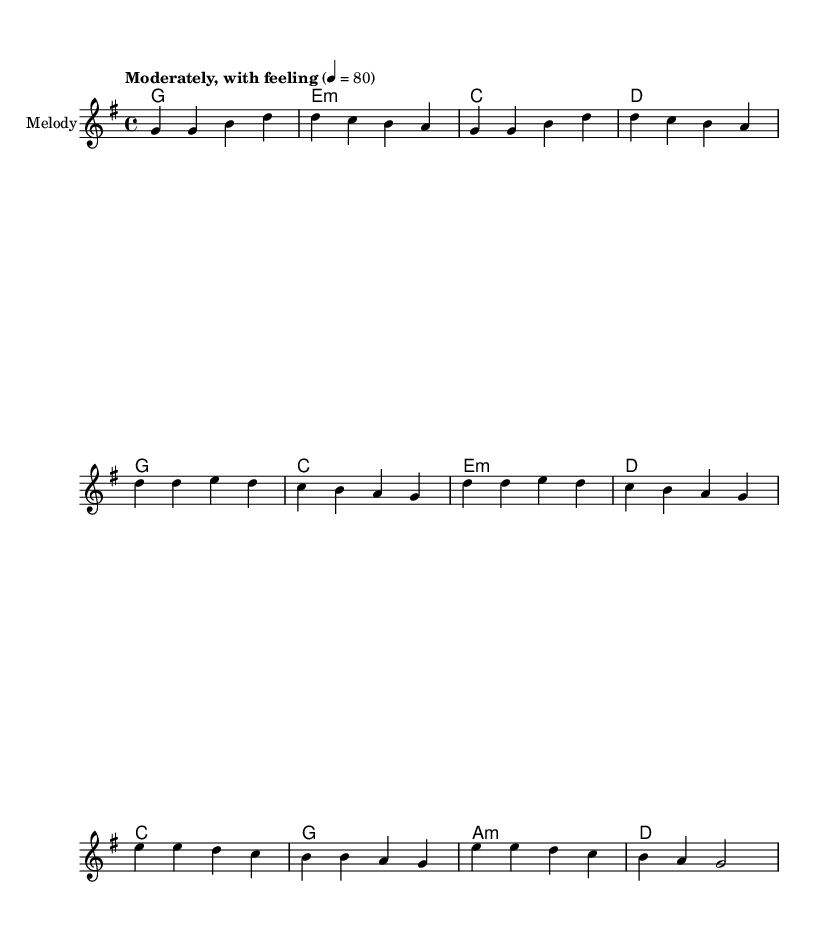What is the key signature of this music? The key signature is G major, which has one sharp (F#).
Answer: G major What is the time signature of this piece? The time signature shown is 4/4, indicating four beats per measure.
Answer: 4/4 What is the tempo marking in the sheet music? The tempo marking indicates "Moderately, with feeling" set at 80 beats per minute.
Answer: Moderately, with feeling How many verses are present in the lyrics? There is one verse represented in the lyrics of the piece.
Answer: One What do the lyrics in the chorus emphasize about community service? The lyrics in the chorus emphasize unity in service and strength of community, focusing on collaborative efforts to effect change.
Answer: Unity in service Which section of the music introduces the theme of compassion? The bridge section of the music introduces the theme of compassion and building a better world together.
Answer: Bridge 